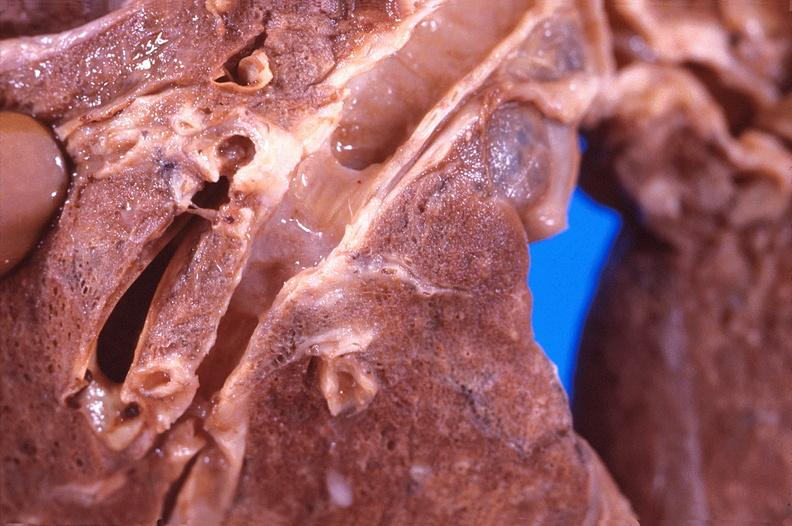where is this?
Answer the question using a single word or phrase. Lung 